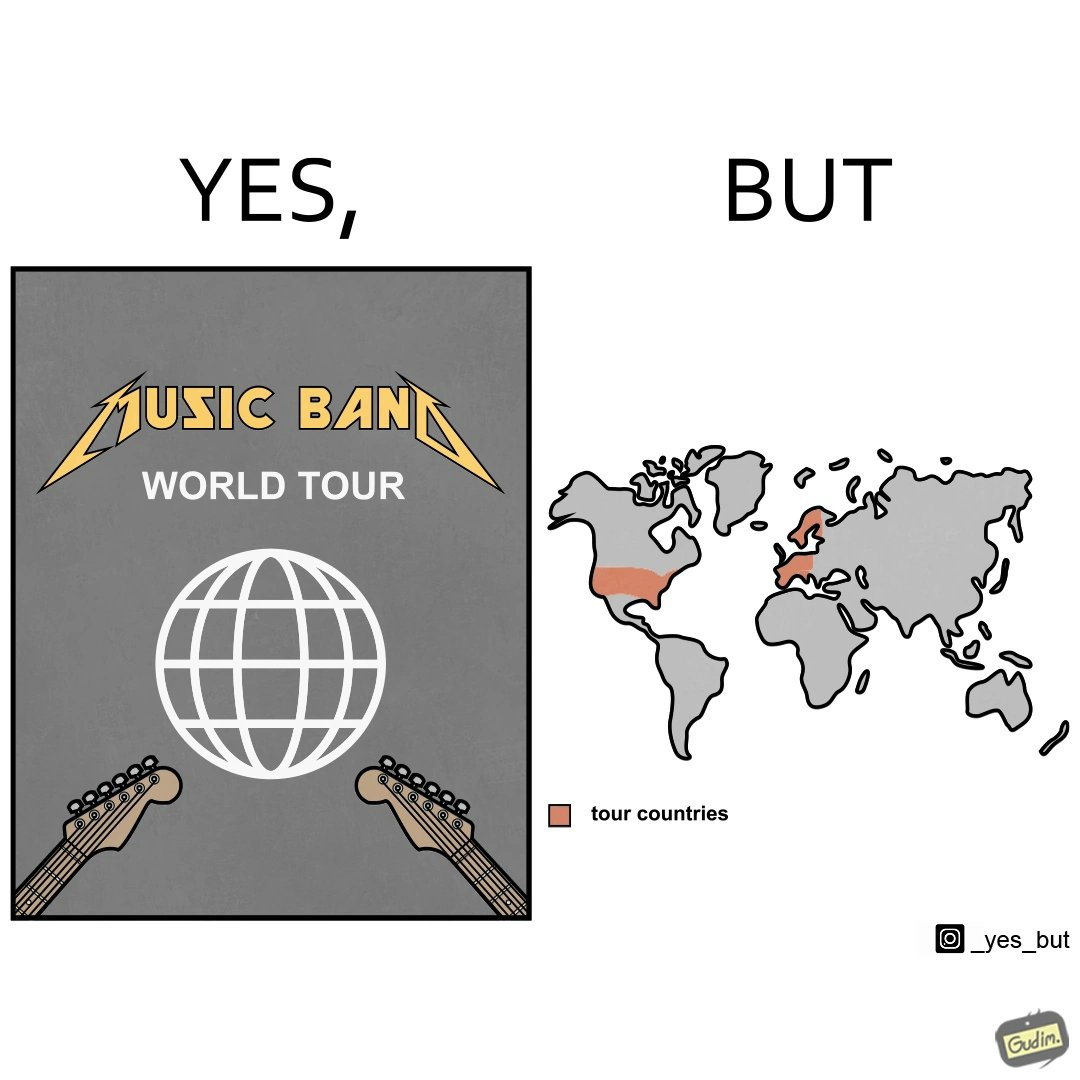Provide a description of this image. The image is ironic, because in the first image some musical band is showing its poster of world tour but in the right image only a few countries are highlighted as tour countries 